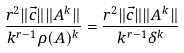<formula> <loc_0><loc_0><loc_500><loc_500>\frac { r ^ { 2 } \| \vec { c } \| \| A ^ { k } \| } { k ^ { r - 1 } \rho ( A ) ^ { k } } = \frac { r ^ { 2 } \| \vec { c } \| \| A ^ { k } \| } { k ^ { r - 1 } \delta ^ { k } }</formula> 